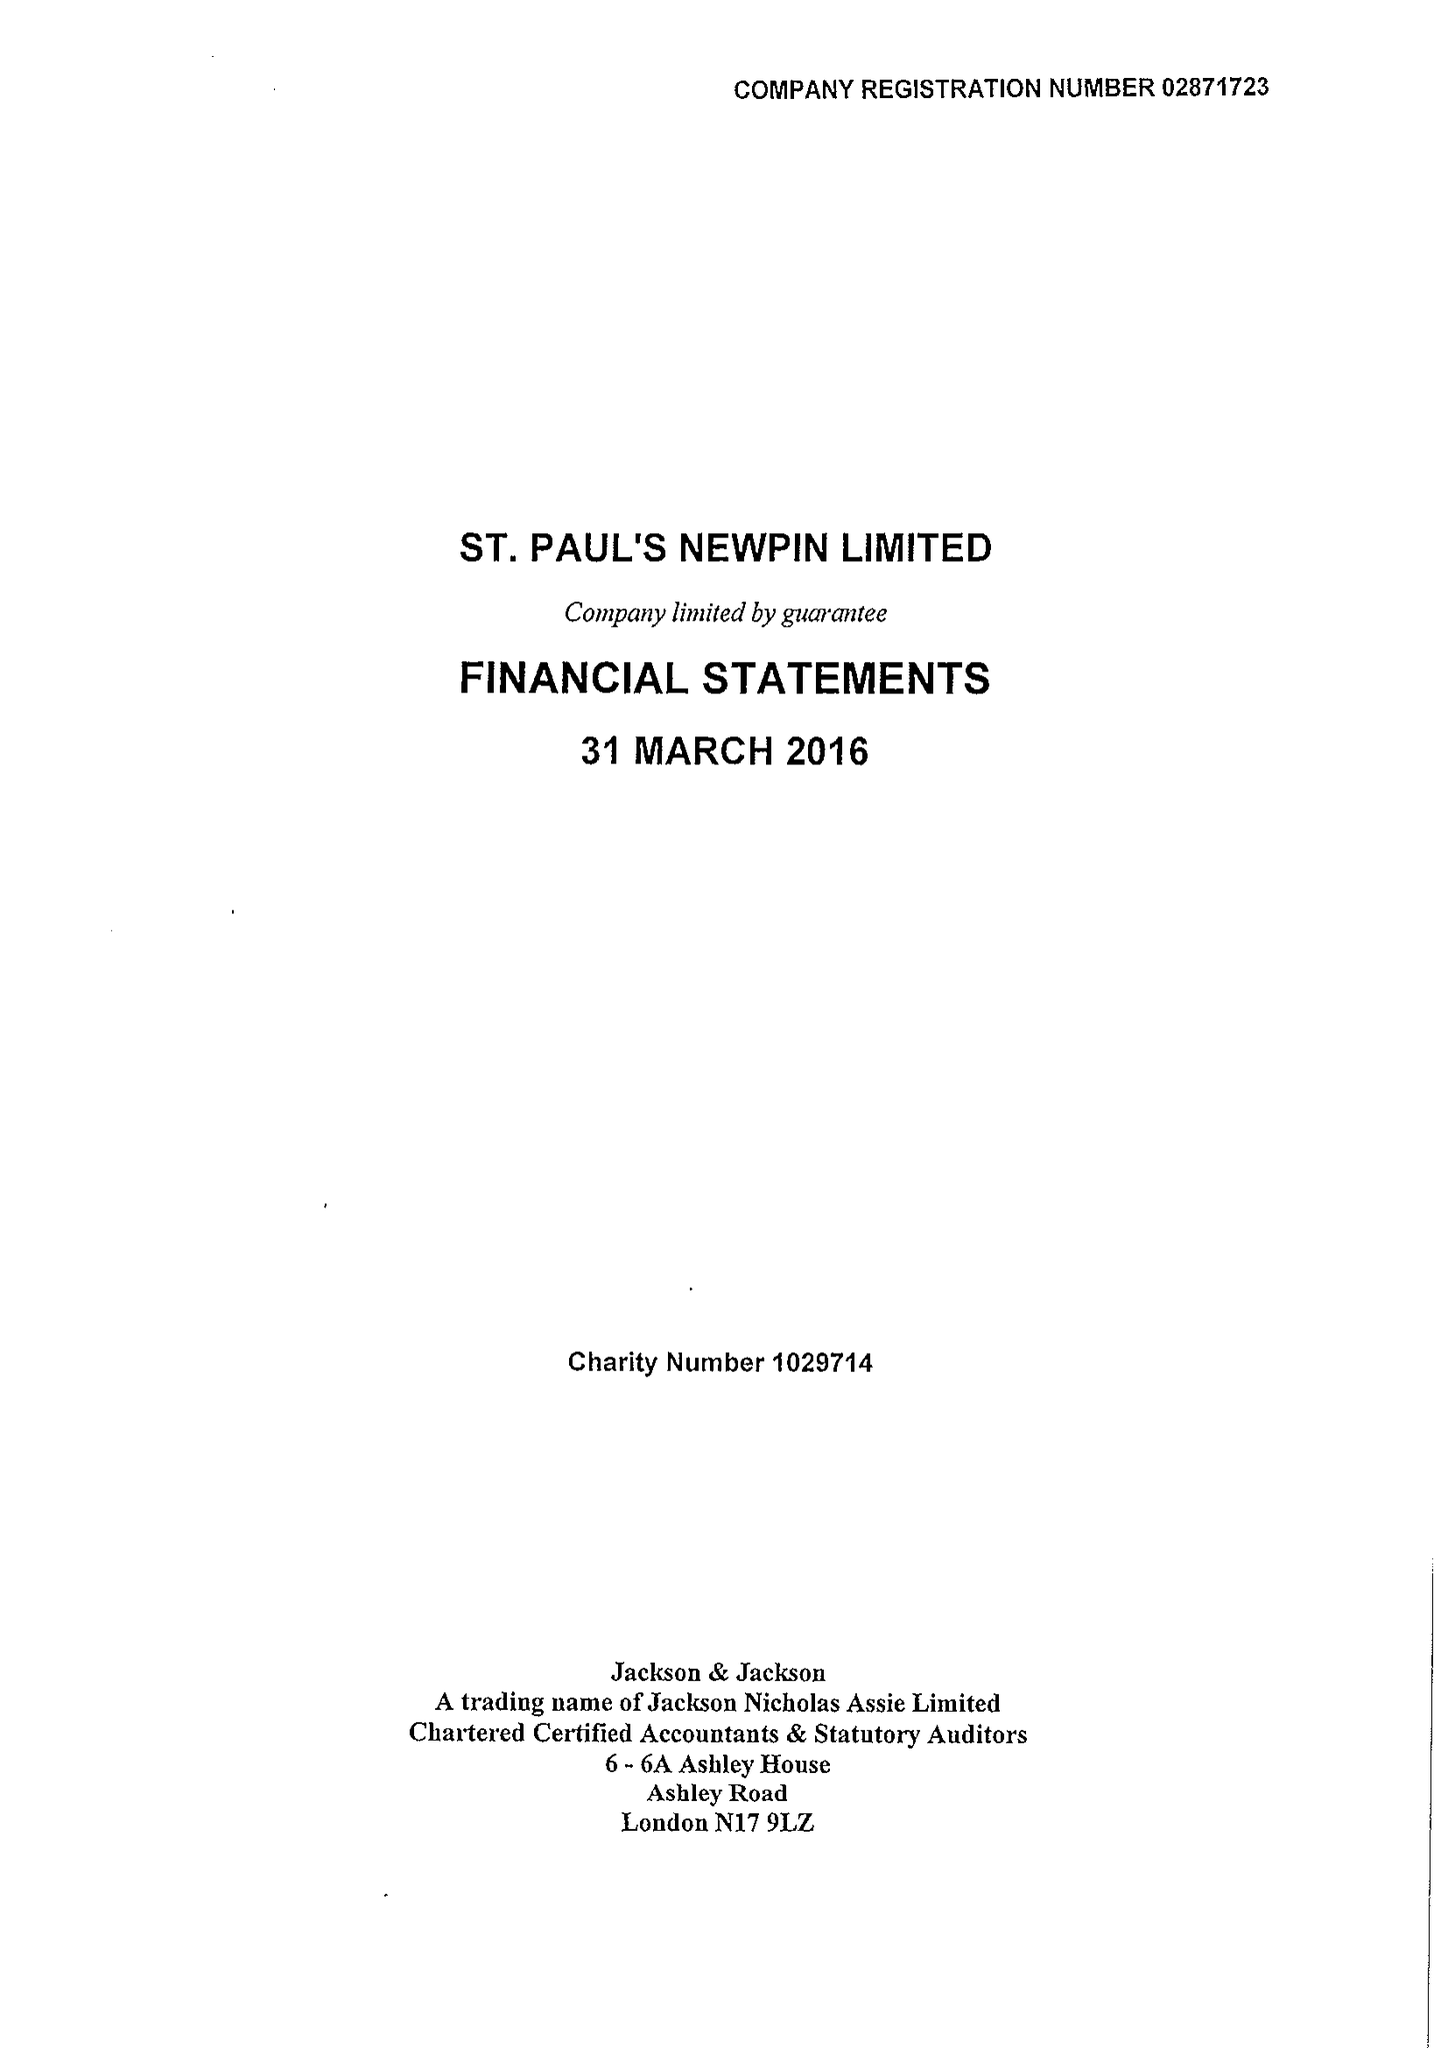What is the value for the report_date?
Answer the question using a single word or phrase. 2016-03-31 